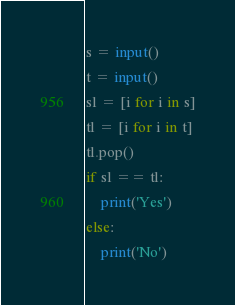<code> <loc_0><loc_0><loc_500><loc_500><_Python_>s = input()
t = input()
sl = [i for i in s]
tl = [i for i in t]
tl.pop()
if sl == tl:
    print('Yes')
else:
    print('No')</code> 